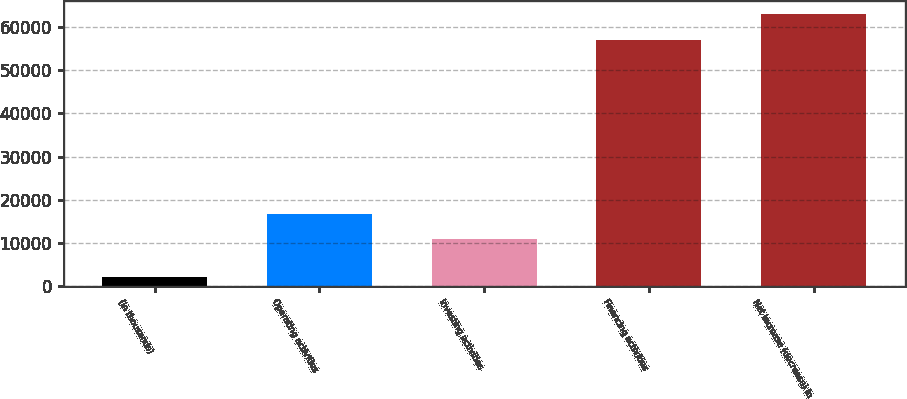Convert chart. <chart><loc_0><loc_0><loc_500><loc_500><bar_chart><fcel>(in thousands)<fcel>Operating activities<fcel>Investing activities<fcel>Financing activities<fcel>Net increase (decrease) in<nl><fcel>2005<fcel>16821.7<fcel>10833<fcel>56989<fcel>62977.7<nl></chart> 